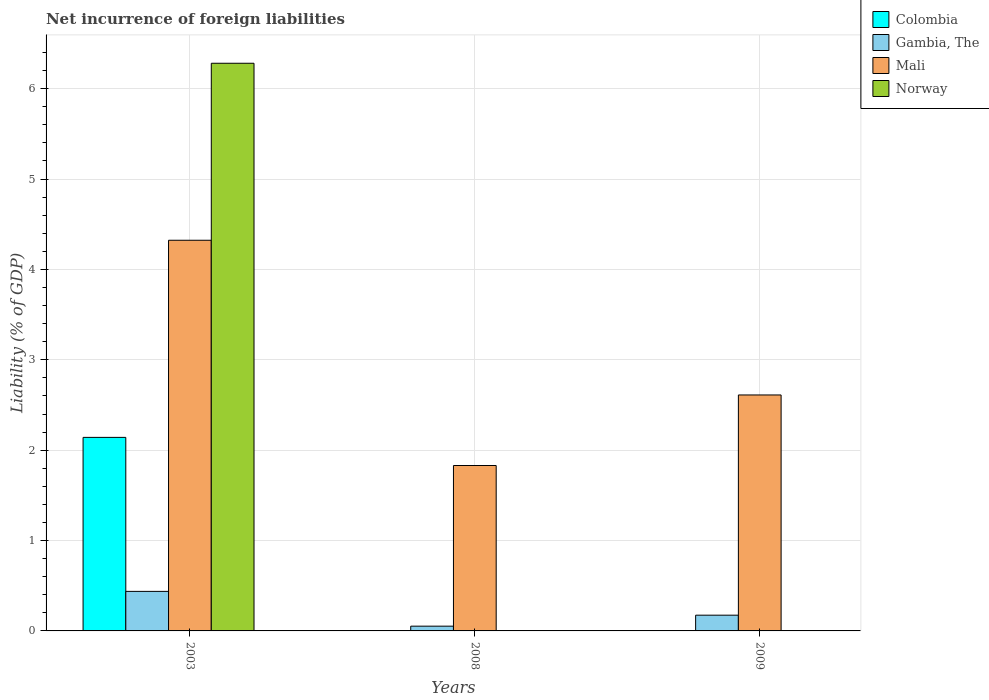How many different coloured bars are there?
Keep it short and to the point. 4. Are the number of bars per tick equal to the number of legend labels?
Offer a very short reply. No. Are the number of bars on each tick of the X-axis equal?
Keep it short and to the point. No. How many bars are there on the 3rd tick from the left?
Your answer should be compact. 2. How many bars are there on the 3rd tick from the right?
Make the answer very short. 4. What is the label of the 1st group of bars from the left?
Provide a short and direct response. 2003. In how many cases, is the number of bars for a given year not equal to the number of legend labels?
Provide a succinct answer. 2. What is the net incurrence of foreign liabilities in Gambia, The in 2003?
Offer a very short reply. 0.44. Across all years, what is the maximum net incurrence of foreign liabilities in Gambia, The?
Provide a short and direct response. 0.44. Across all years, what is the minimum net incurrence of foreign liabilities in Gambia, The?
Offer a terse response. 0.05. In which year was the net incurrence of foreign liabilities in Norway maximum?
Provide a short and direct response. 2003. What is the total net incurrence of foreign liabilities in Gambia, The in the graph?
Offer a very short reply. 0.66. What is the difference between the net incurrence of foreign liabilities in Gambia, The in 2003 and that in 2009?
Offer a very short reply. 0.26. What is the difference between the net incurrence of foreign liabilities in Gambia, The in 2003 and the net incurrence of foreign liabilities in Norway in 2009?
Make the answer very short. 0.44. What is the average net incurrence of foreign liabilities in Gambia, The per year?
Provide a succinct answer. 0.22. In the year 2003, what is the difference between the net incurrence of foreign liabilities in Colombia and net incurrence of foreign liabilities in Gambia, The?
Provide a short and direct response. 1.7. In how many years, is the net incurrence of foreign liabilities in Colombia greater than 5 %?
Offer a terse response. 0. What is the ratio of the net incurrence of foreign liabilities in Mali in 2003 to that in 2008?
Your answer should be very brief. 2.36. Is the net incurrence of foreign liabilities in Gambia, The in 2003 less than that in 2009?
Ensure brevity in your answer.  No. What is the difference between the highest and the second highest net incurrence of foreign liabilities in Mali?
Give a very brief answer. 1.71. What is the difference between the highest and the lowest net incurrence of foreign liabilities in Norway?
Offer a very short reply. 6.28. In how many years, is the net incurrence of foreign liabilities in Mali greater than the average net incurrence of foreign liabilities in Mali taken over all years?
Provide a succinct answer. 1. How many years are there in the graph?
Ensure brevity in your answer.  3. Are the values on the major ticks of Y-axis written in scientific E-notation?
Keep it short and to the point. No. How many legend labels are there?
Your answer should be compact. 4. How are the legend labels stacked?
Give a very brief answer. Vertical. What is the title of the graph?
Provide a succinct answer. Net incurrence of foreign liabilities. What is the label or title of the Y-axis?
Give a very brief answer. Liability (% of GDP). What is the Liability (% of GDP) in Colombia in 2003?
Ensure brevity in your answer.  2.14. What is the Liability (% of GDP) of Gambia, The in 2003?
Your answer should be very brief. 0.44. What is the Liability (% of GDP) in Mali in 2003?
Offer a terse response. 4.32. What is the Liability (% of GDP) of Norway in 2003?
Give a very brief answer. 6.28. What is the Liability (% of GDP) of Gambia, The in 2008?
Give a very brief answer. 0.05. What is the Liability (% of GDP) of Mali in 2008?
Provide a short and direct response. 1.83. What is the Liability (% of GDP) of Colombia in 2009?
Your answer should be compact. 0. What is the Liability (% of GDP) in Gambia, The in 2009?
Provide a short and direct response. 0.17. What is the Liability (% of GDP) of Mali in 2009?
Offer a very short reply. 2.61. What is the Liability (% of GDP) of Norway in 2009?
Keep it short and to the point. 0. Across all years, what is the maximum Liability (% of GDP) of Colombia?
Offer a very short reply. 2.14. Across all years, what is the maximum Liability (% of GDP) of Gambia, The?
Provide a short and direct response. 0.44. Across all years, what is the maximum Liability (% of GDP) of Mali?
Provide a short and direct response. 4.32. Across all years, what is the maximum Liability (% of GDP) of Norway?
Give a very brief answer. 6.28. Across all years, what is the minimum Liability (% of GDP) in Gambia, The?
Offer a terse response. 0.05. Across all years, what is the minimum Liability (% of GDP) of Mali?
Your response must be concise. 1.83. What is the total Liability (% of GDP) in Colombia in the graph?
Give a very brief answer. 2.14. What is the total Liability (% of GDP) of Gambia, The in the graph?
Offer a terse response. 0.66. What is the total Liability (% of GDP) in Mali in the graph?
Keep it short and to the point. 8.76. What is the total Liability (% of GDP) in Norway in the graph?
Make the answer very short. 6.28. What is the difference between the Liability (% of GDP) in Gambia, The in 2003 and that in 2008?
Make the answer very short. 0.38. What is the difference between the Liability (% of GDP) of Mali in 2003 and that in 2008?
Keep it short and to the point. 2.49. What is the difference between the Liability (% of GDP) of Gambia, The in 2003 and that in 2009?
Provide a succinct answer. 0.26. What is the difference between the Liability (% of GDP) of Mali in 2003 and that in 2009?
Provide a short and direct response. 1.71. What is the difference between the Liability (% of GDP) in Gambia, The in 2008 and that in 2009?
Offer a terse response. -0.12. What is the difference between the Liability (% of GDP) of Mali in 2008 and that in 2009?
Your response must be concise. -0.78. What is the difference between the Liability (% of GDP) in Colombia in 2003 and the Liability (% of GDP) in Gambia, The in 2008?
Provide a succinct answer. 2.09. What is the difference between the Liability (% of GDP) of Colombia in 2003 and the Liability (% of GDP) of Mali in 2008?
Provide a short and direct response. 0.31. What is the difference between the Liability (% of GDP) in Gambia, The in 2003 and the Liability (% of GDP) in Mali in 2008?
Ensure brevity in your answer.  -1.39. What is the difference between the Liability (% of GDP) of Colombia in 2003 and the Liability (% of GDP) of Gambia, The in 2009?
Your answer should be very brief. 1.97. What is the difference between the Liability (% of GDP) of Colombia in 2003 and the Liability (% of GDP) of Mali in 2009?
Keep it short and to the point. -0.47. What is the difference between the Liability (% of GDP) in Gambia, The in 2003 and the Liability (% of GDP) in Mali in 2009?
Offer a terse response. -2.17. What is the difference between the Liability (% of GDP) in Gambia, The in 2008 and the Liability (% of GDP) in Mali in 2009?
Ensure brevity in your answer.  -2.56. What is the average Liability (% of GDP) of Colombia per year?
Offer a terse response. 0.71. What is the average Liability (% of GDP) of Gambia, The per year?
Give a very brief answer. 0.22. What is the average Liability (% of GDP) of Mali per year?
Offer a very short reply. 2.92. What is the average Liability (% of GDP) in Norway per year?
Your response must be concise. 2.09. In the year 2003, what is the difference between the Liability (% of GDP) of Colombia and Liability (% of GDP) of Gambia, The?
Provide a short and direct response. 1.7. In the year 2003, what is the difference between the Liability (% of GDP) of Colombia and Liability (% of GDP) of Mali?
Make the answer very short. -2.18. In the year 2003, what is the difference between the Liability (% of GDP) of Colombia and Liability (% of GDP) of Norway?
Give a very brief answer. -4.14. In the year 2003, what is the difference between the Liability (% of GDP) in Gambia, The and Liability (% of GDP) in Mali?
Give a very brief answer. -3.89. In the year 2003, what is the difference between the Liability (% of GDP) of Gambia, The and Liability (% of GDP) of Norway?
Your answer should be compact. -5.84. In the year 2003, what is the difference between the Liability (% of GDP) of Mali and Liability (% of GDP) of Norway?
Offer a very short reply. -1.96. In the year 2008, what is the difference between the Liability (% of GDP) in Gambia, The and Liability (% of GDP) in Mali?
Make the answer very short. -1.78. In the year 2009, what is the difference between the Liability (% of GDP) of Gambia, The and Liability (% of GDP) of Mali?
Provide a short and direct response. -2.44. What is the ratio of the Liability (% of GDP) in Gambia, The in 2003 to that in 2008?
Keep it short and to the point. 8.3. What is the ratio of the Liability (% of GDP) of Mali in 2003 to that in 2008?
Give a very brief answer. 2.36. What is the ratio of the Liability (% of GDP) of Gambia, The in 2003 to that in 2009?
Your answer should be very brief. 2.51. What is the ratio of the Liability (% of GDP) of Mali in 2003 to that in 2009?
Keep it short and to the point. 1.66. What is the ratio of the Liability (% of GDP) in Gambia, The in 2008 to that in 2009?
Offer a very short reply. 0.3. What is the ratio of the Liability (% of GDP) of Mali in 2008 to that in 2009?
Your answer should be very brief. 0.7. What is the difference between the highest and the second highest Liability (% of GDP) of Gambia, The?
Offer a terse response. 0.26. What is the difference between the highest and the second highest Liability (% of GDP) of Mali?
Give a very brief answer. 1.71. What is the difference between the highest and the lowest Liability (% of GDP) of Colombia?
Your response must be concise. 2.14. What is the difference between the highest and the lowest Liability (% of GDP) of Gambia, The?
Make the answer very short. 0.38. What is the difference between the highest and the lowest Liability (% of GDP) of Mali?
Give a very brief answer. 2.49. What is the difference between the highest and the lowest Liability (% of GDP) of Norway?
Give a very brief answer. 6.28. 